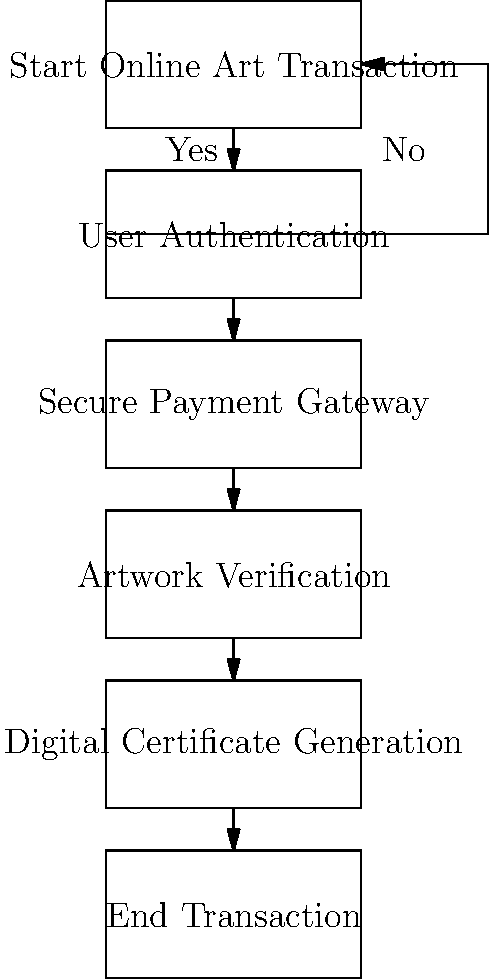In the flowchart depicting the security measures for online art transactions, which step comes immediately after the "Secure Payment Gateway" and before the "Digital Certificate Generation"? To answer this question, let's follow the steps in the flowchart:

1. The process starts with "Start Online Art Transaction".
2. It then moves to "User Authentication".
3. After authentication, it proceeds to "Secure Payment Gateway".
4. The next step after "Secure Payment Gateway" is "Artwork Verification".
5. Following "Artwork Verification" is "Digital Certificate Generation".
6. Finally, the process ends with "End Transaction".

By examining the flowchart, we can clearly see that "Artwork Verification" is the step that comes immediately after "Secure Payment Gateway" and before "Digital Certificate Generation".

This step is crucial in online art transactions as it ensures the authenticity and condition of the artwork being sold, which is particularly important for an art dealer utilizing modern technology for virtual auctions.
Answer: Artwork Verification 